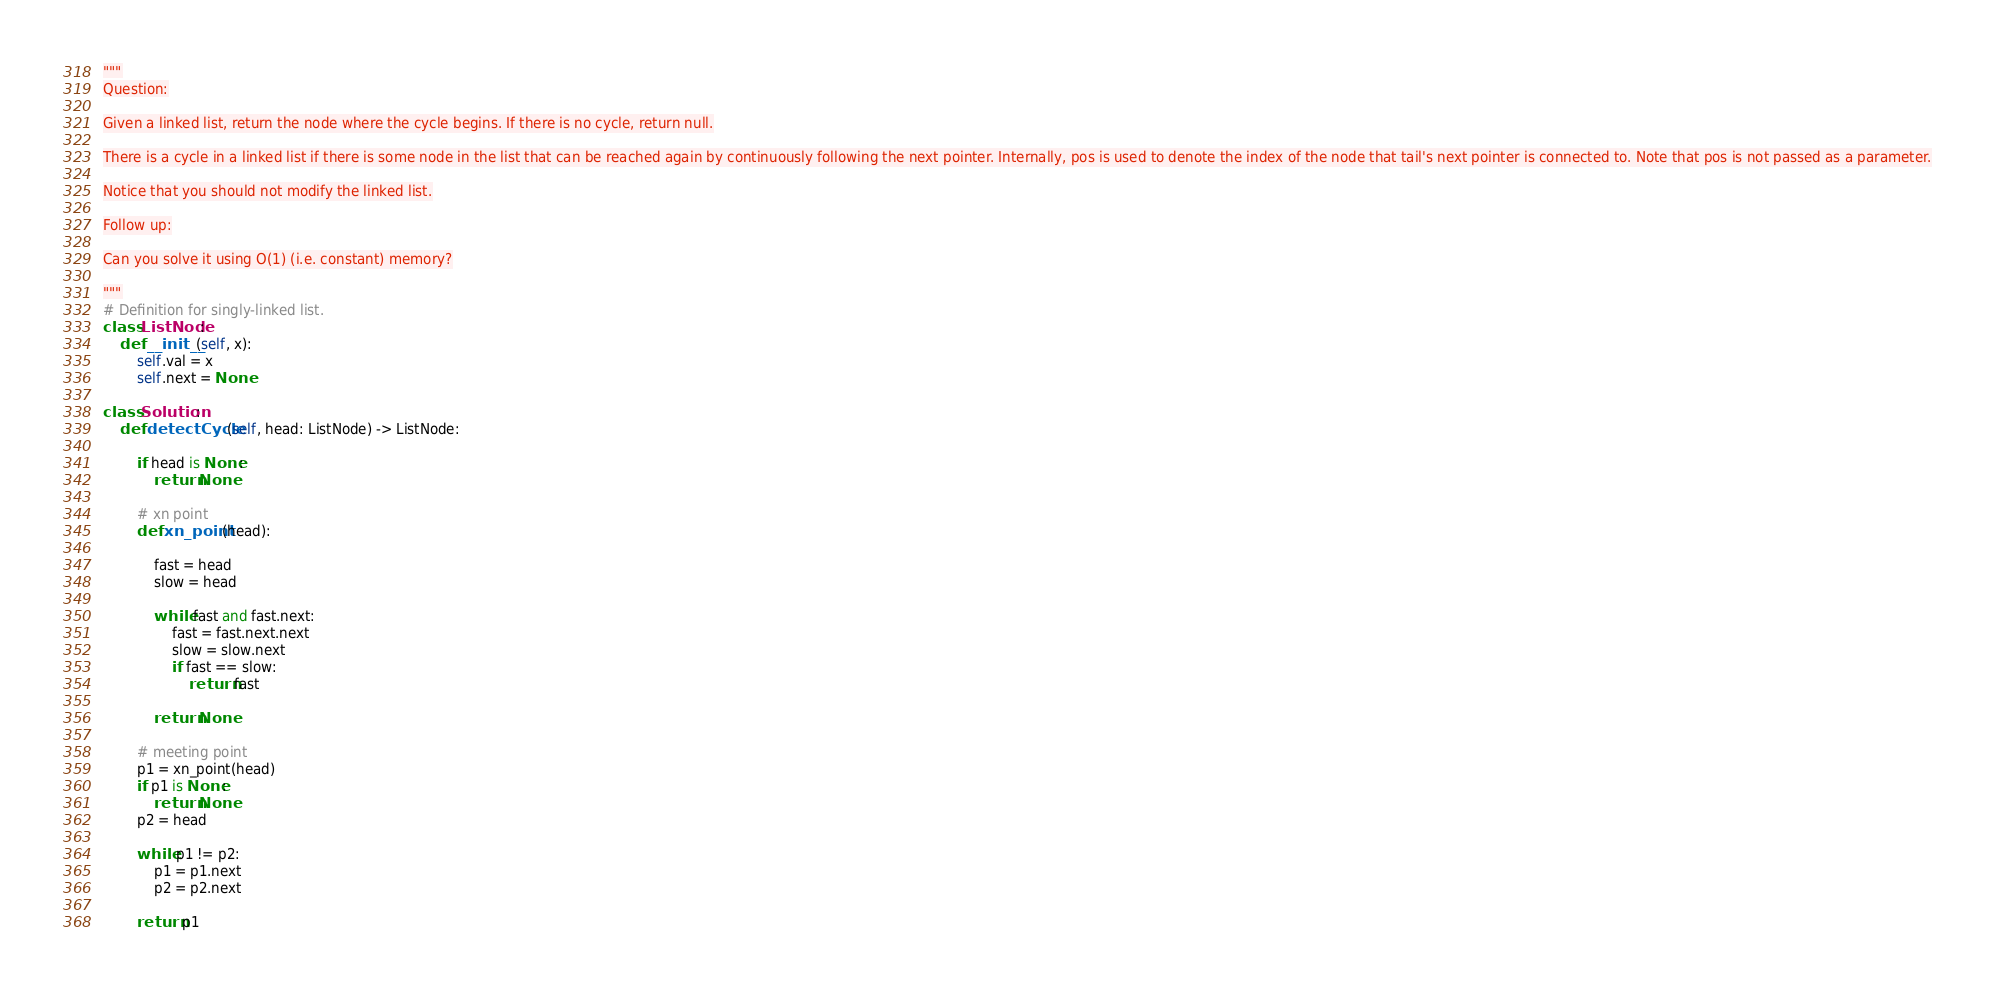<code> <loc_0><loc_0><loc_500><loc_500><_Python_>"""
Question:

Given a linked list, return the node where the cycle begins. If there is no cycle, return null.

There is a cycle in a linked list if there is some node in the list that can be reached again by continuously following the next pointer. Internally, pos is used to denote the index of the node that tail's next pointer is connected to. Note that pos is not passed as a parameter.

Notice that you should not modify the linked list.

Follow up:

Can you solve it using O(1) (i.e. constant) memory?

"""
# Definition for singly-linked list.
class ListNode:
    def __init__(self, x):
        self.val = x
        self.next = None

class Solution:
    def detectCycle(self, head: ListNode) -> ListNode:
        
        if head is None:
            return None
        
        # xn point
        def xn_point(head):

            fast = head
            slow = head
            
            while fast and fast.next:
                fast = fast.next.next
                slow = slow.next
                if fast == slow:
                    return fast
                
            return None
        
        # meeting point
        p1 = xn_point(head)
        if p1 is None:
            return None
        p2 = head
        
        while p1 != p2:
            p1 = p1.next
            p2 = p2.next
            
        return p1
</code> 